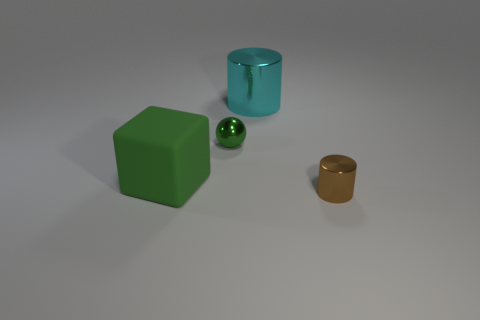Add 4 green shiny balls. How many objects exist? 8 Subtract all blocks. How many objects are left? 3 Subtract 1 green spheres. How many objects are left? 3 Subtract all cyan balls. Subtract all yellow cylinders. How many balls are left? 1 Subtract all large rubber things. Subtract all large green cubes. How many objects are left? 2 Add 4 small green balls. How many small green balls are left? 5 Add 2 tiny things. How many tiny things exist? 4 